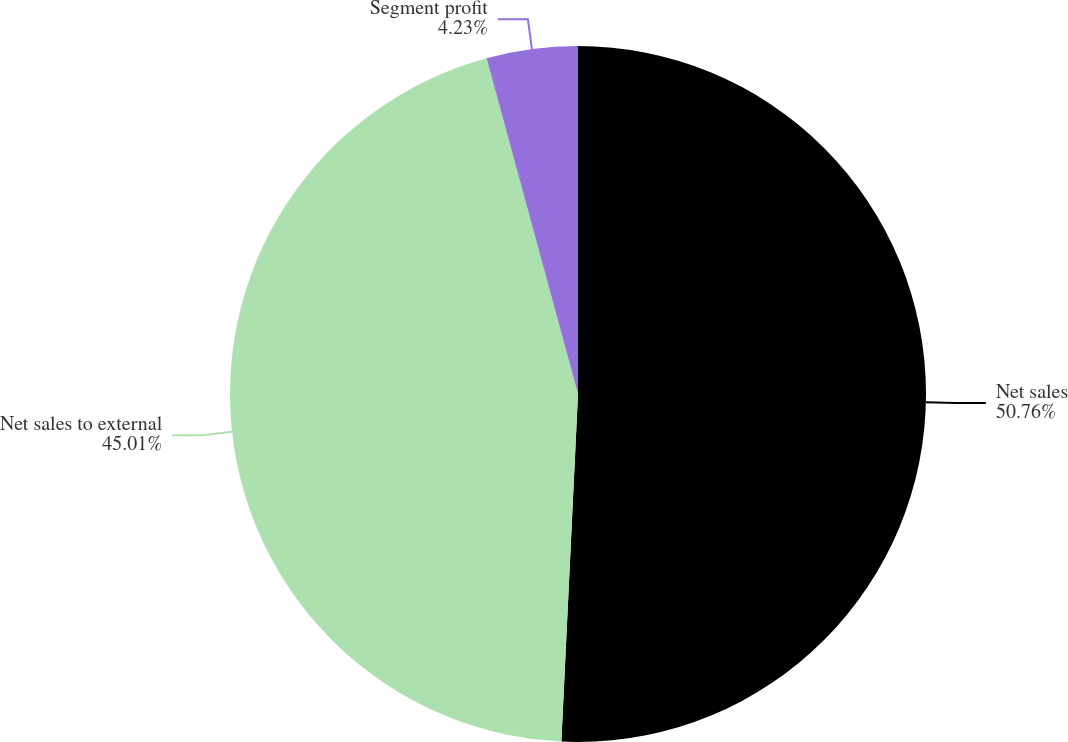Convert chart to OTSL. <chart><loc_0><loc_0><loc_500><loc_500><pie_chart><fcel>Net sales<fcel>Net sales to external<fcel>Segment profit<nl><fcel>50.76%<fcel>45.01%<fcel>4.23%<nl></chart> 